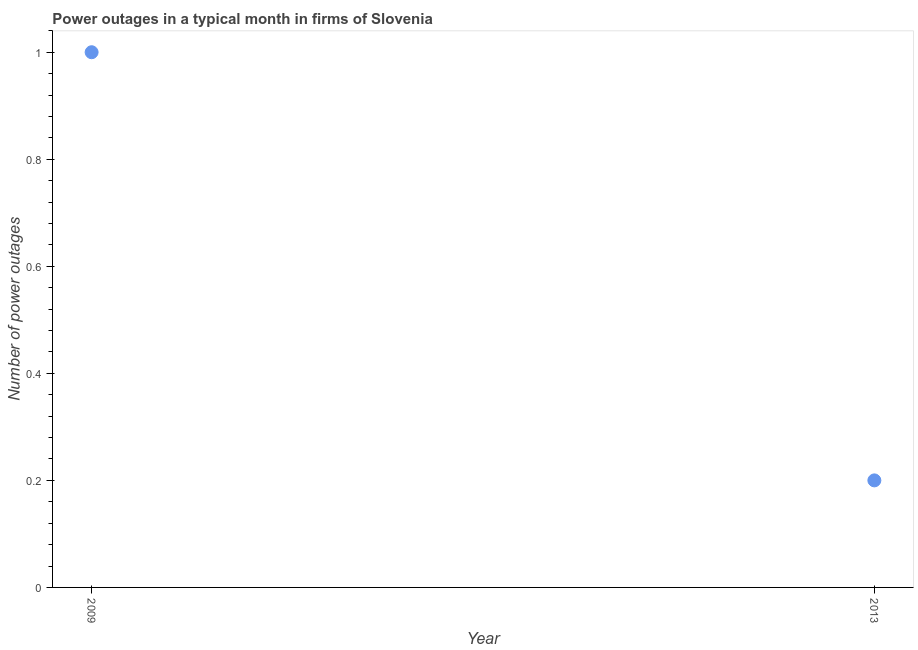What is the number of power outages in 2013?
Your answer should be very brief. 0.2. In which year was the number of power outages maximum?
Offer a terse response. 2009. What is the difference between the number of power outages in 2009 and 2013?
Your response must be concise. 0.8. What is the average number of power outages per year?
Ensure brevity in your answer.  0.6. What is the median number of power outages?
Your answer should be very brief. 0.6. In how many years, is the number of power outages greater than 1 ?
Offer a terse response. 0. In how many years, is the number of power outages greater than the average number of power outages taken over all years?
Keep it short and to the point. 1. Does the number of power outages monotonically increase over the years?
Offer a very short reply. No. How many dotlines are there?
Provide a succinct answer. 1. Are the values on the major ticks of Y-axis written in scientific E-notation?
Make the answer very short. No. Does the graph contain any zero values?
Provide a succinct answer. No. What is the title of the graph?
Provide a short and direct response. Power outages in a typical month in firms of Slovenia. What is the label or title of the X-axis?
Make the answer very short. Year. What is the label or title of the Y-axis?
Provide a short and direct response. Number of power outages. What is the difference between the Number of power outages in 2009 and 2013?
Give a very brief answer. 0.8. What is the ratio of the Number of power outages in 2009 to that in 2013?
Your answer should be compact. 5. 